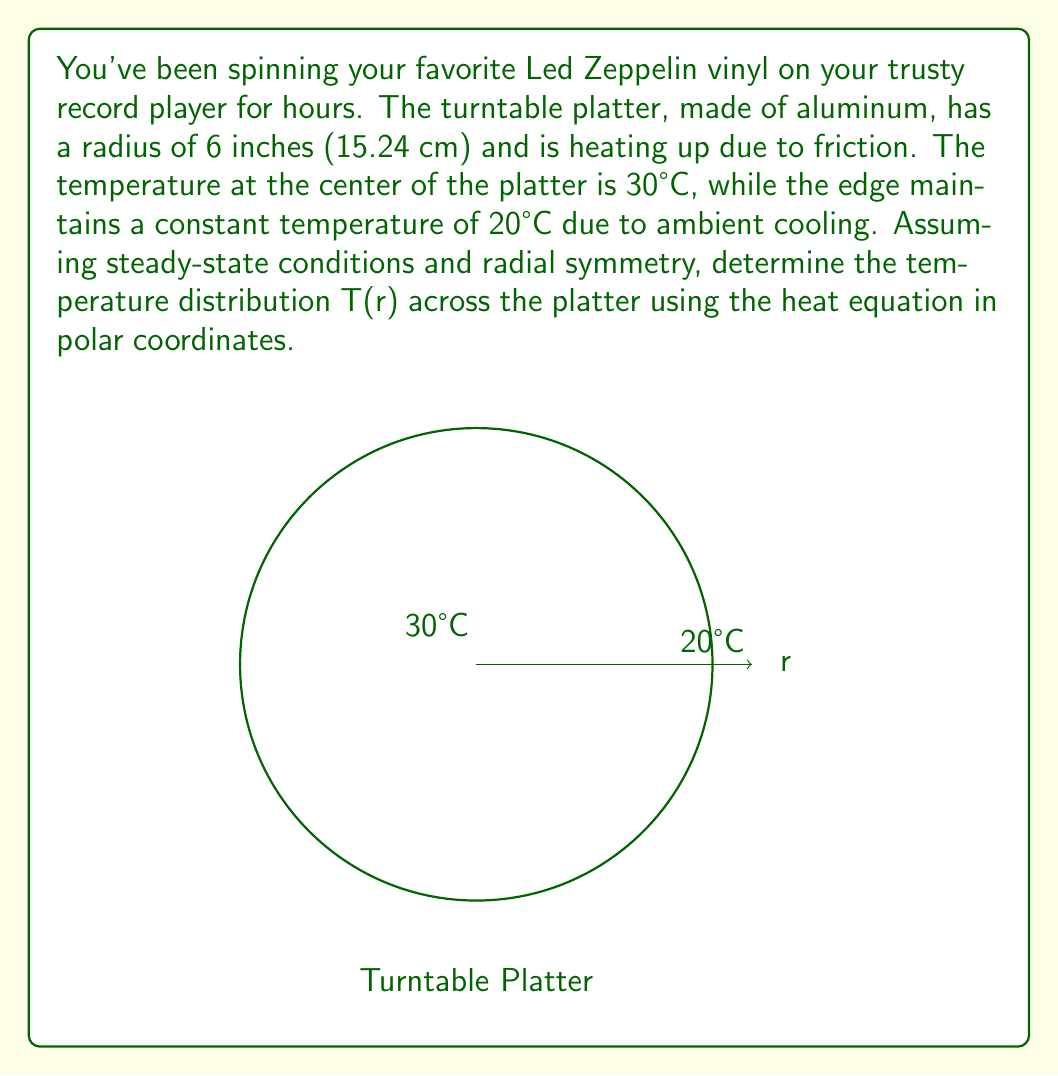Can you answer this question? Let's approach this step-by-step:

1) The steady-state heat equation in polar coordinates with radial symmetry is:

   $$\frac{1}{r}\frac{d}{dr}\left(r\frac{dT}{dr}\right) = 0$$

2) Integrating once with respect to r:

   $$r\frac{dT}{dr} = C_1$$

3) Separating variables and integrating again:

   $$T(r) = C_1 \ln(r) + C_2$$

4) Now, we apply the boundary conditions:
   At r = 0 (center), T = 30°C
   At r = R = 6 inches = 15.24 cm, T = 20°C

5) Applying the condition at r = R:

   $$20 = C_1 \ln(15.24) + C_2$$

6) We can't apply the condition at r = 0 directly because ln(0) is undefined. Instead, we use the fact that the temperature must be finite at r = 0, which means C_1 must be 0.

7) With C_1 = 0, our equation becomes:

   $$T(r) = C_2 = 20°C$$

8) This means the temperature is constant across the entire platter at 20°C.

9) However, this contradicts our initial condition at the center. This discrepancy arises because the steady-state solution with these boundary conditions is physically impossible. In reality, there would be a heat source at the center maintaining the higher temperature.
Answer: The steady-state solution is physically impossible with the given conditions. 